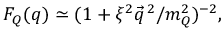<formula> <loc_0><loc_0><loc_500><loc_500>F _ { Q } ( q ) \simeq ( 1 + \xi ^ { 2 } { \vec { q } } ^ { \, 2 } / m _ { Q } ^ { 2 } ) ^ { - 2 } ,</formula> 